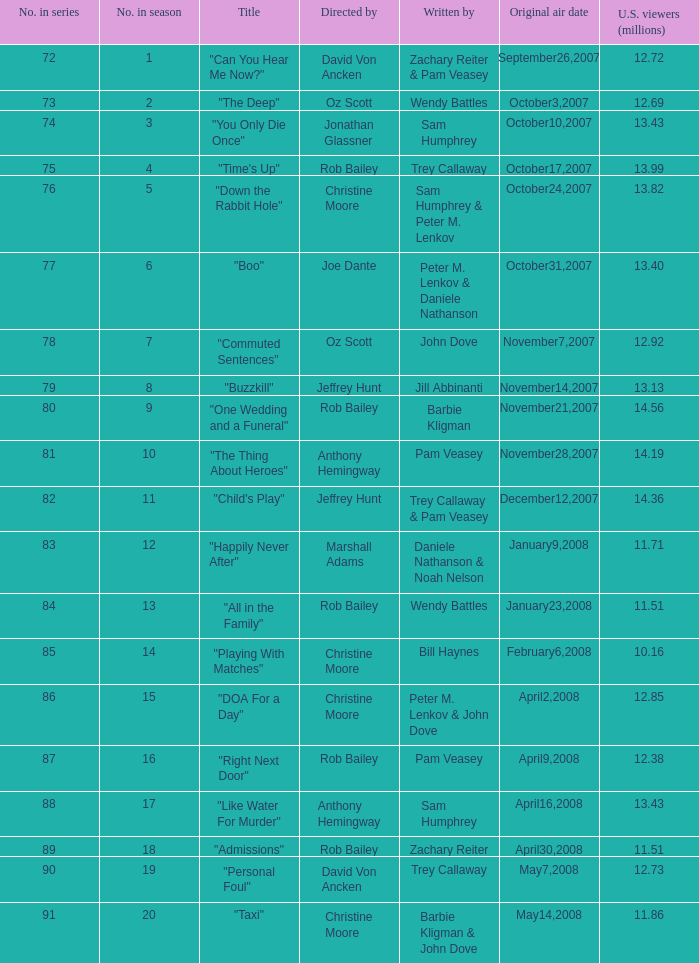How many episodes were watched by 12.72 million U.S. viewers? 1.0. 